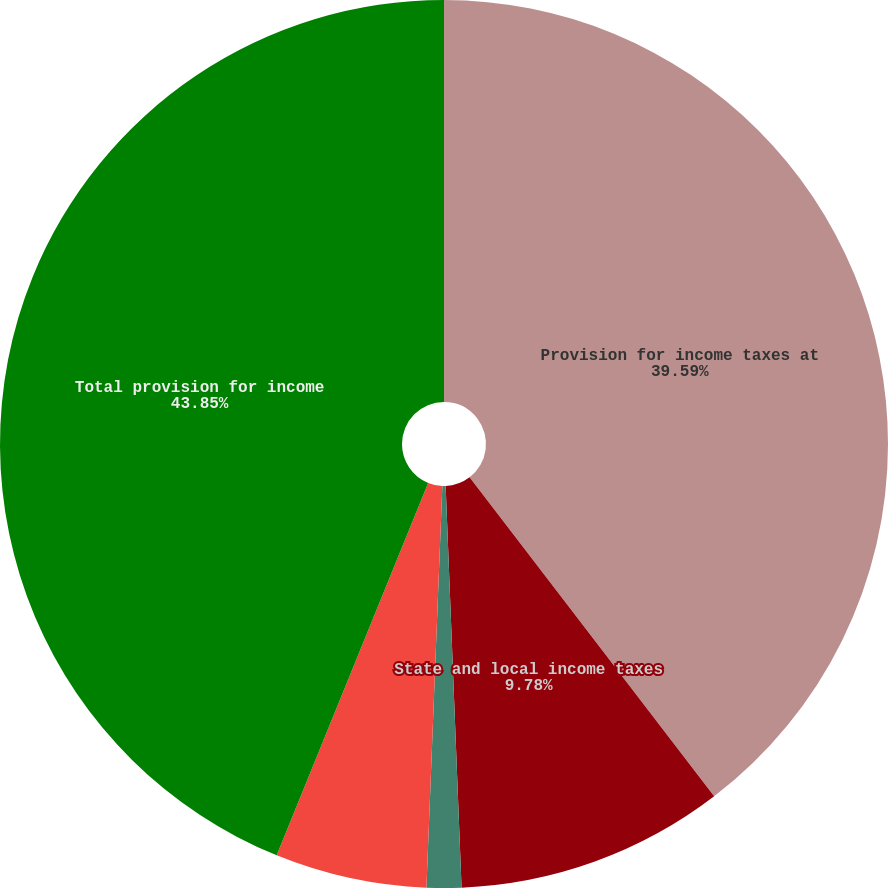Convert chart. <chart><loc_0><loc_0><loc_500><loc_500><pie_chart><fcel>Provision for income taxes at<fcel>State and local income taxes<fcel>Foreign income taxed at<fcel>Other<fcel>Total provision for income<nl><fcel>39.59%<fcel>9.78%<fcel>1.26%<fcel>5.52%<fcel>43.85%<nl></chart> 